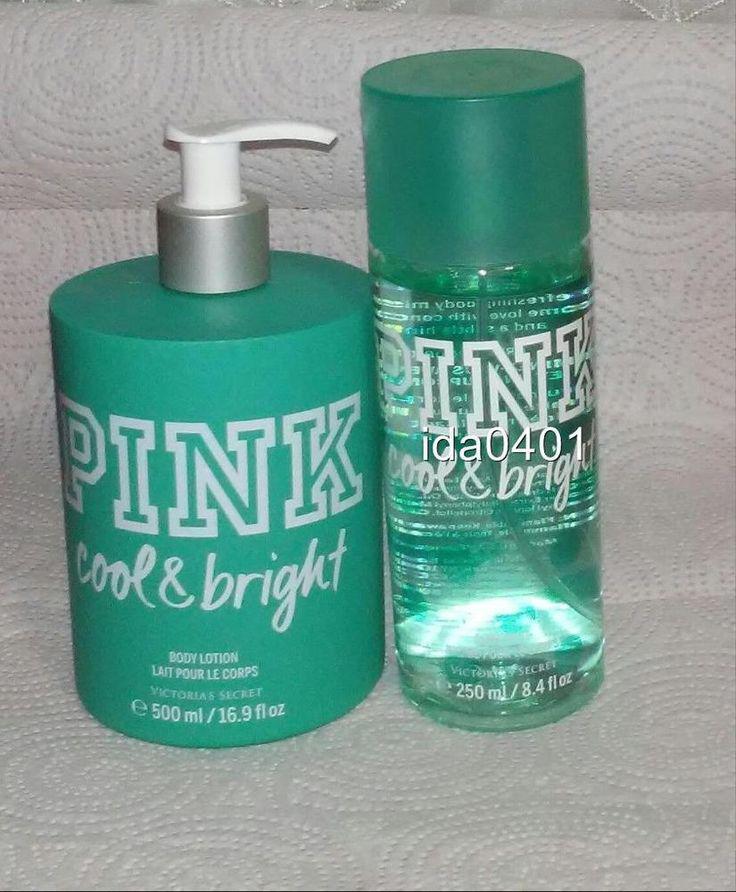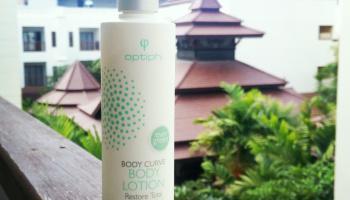The first image is the image on the left, the second image is the image on the right. Given the left and right images, does the statement "An image contains only two side-by-side products, which feature green in the packaging." hold true? Answer yes or no. Yes. The first image is the image on the left, the second image is the image on the right. For the images displayed, is the sentence "Two containers stand together in the image on the left." factually correct? Answer yes or no. Yes. 